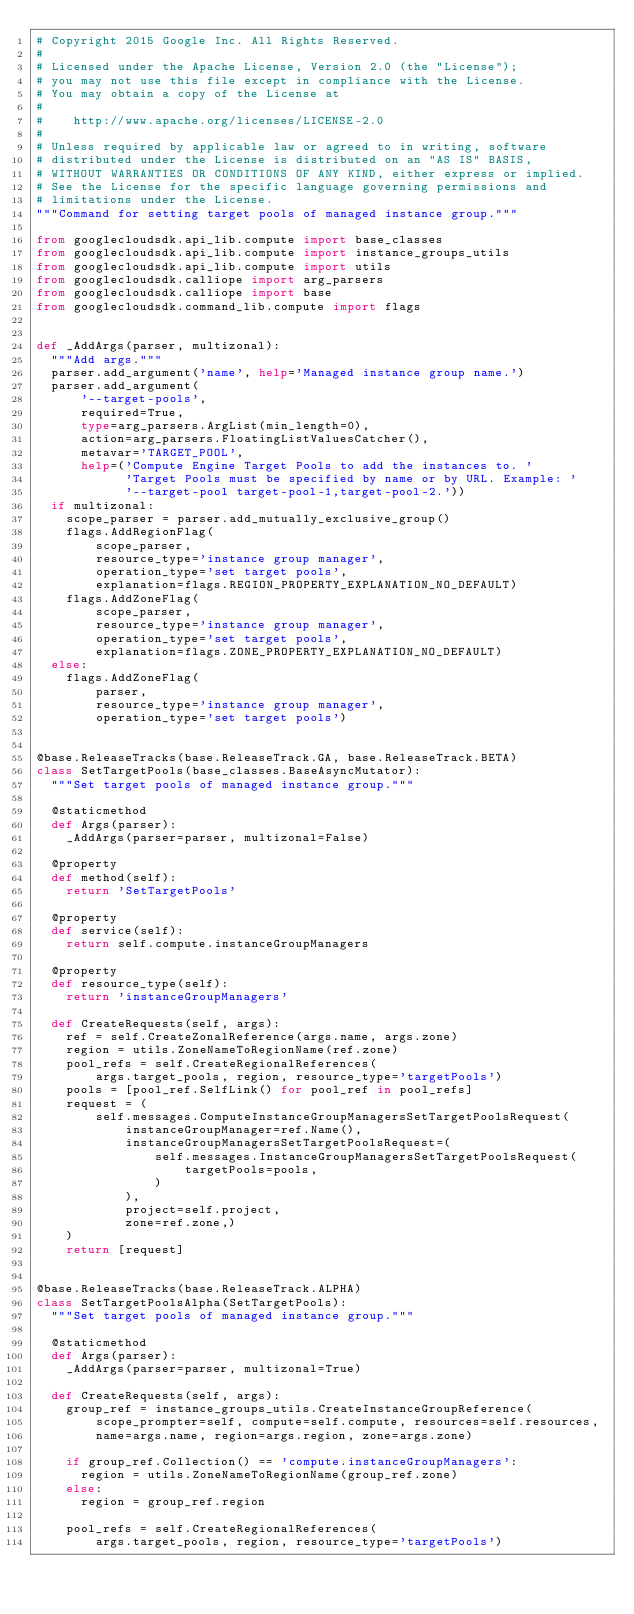Convert code to text. <code><loc_0><loc_0><loc_500><loc_500><_Python_># Copyright 2015 Google Inc. All Rights Reserved.
#
# Licensed under the Apache License, Version 2.0 (the "License");
# you may not use this file except in compliance with the License.
# You may obtain a copy of the License at
#
#    http://www.apache.org/licenses/LICENSE-2.0
#
# Unless required by applicable law or agreed to in writing, software
# distributed under the License is distributed on an "AS IS" BASIS,
# WITHOUT WARRANTIES OR CONDITIONS OF ANY KIND, either express or implied.
# See the License for the specific language governing permissions and
# limitations under the License.
"""Command for setting target pools of managed instance group."""

from googlecloudsdk.api_lib.compute import base_classes
from googlecloudsdk.api_lib.compute import instance_groups_utils
from googlecloudsdk.api_lib.compute import utils
from googlecloudsdk.calliope import arg_parsers
from googlecloudsdk.calliope import base
from googlecloudsdk.command_lib.compute import flags


def _AddArgs(parser, multizonal):
  """Add args."""
  parser.add_argument('name', help='Managed instance group name.')
  parser.add_argument(
      '--target-pools',
      required=True,
      type=arg_parsers.ArgList(min_length=0),
      action=arg_parsers.FloatingListValuesCatcher(),
      metavar='TARGET_POOL',
      help=('Compute Engine Target Pools to add the instances to. '
            'Target Pools must be specified by name or by URL. Example: '
            '--target-pool target-pool-1,target-pool-2.'))
  if multizonal:
    scope_parser = parser.add_mutually_exclusive_group()
    flags.AddRegionFlag(
        scope_parser,
        resource_type='instance group manager',
        operation_type='set target pools',
        explanation=flags.REGION_PROPERTY_EXPLANATION_NO_DEFAULT)
    flags.AddZoneFlag(
        scope_parser,
        resource_type='instance group manager',
        operation_type='set target pools',
        explanation=flags.ZONE_PROPERTY_EXPLANATION_NO_DEFAULT)
  else:
    flags.AddZoneFlag(
        parser,
        resource_type='instance group manager',
        operation_type='set target pools')


@base.ReleaseTracks(base.ReleaseTrack.GA, base.ReleaseTrack.BETA)
class SetTargetPools(base_classes.BaseAsyncMutator):
  """Set target pools of managed instance group."""

  @staticmethod
  def Args(parser):
    _AddArgs(parser=parser, multizonal=False)

  @property
  def method(self):
    return 'SetTargetPools'

  @property
  def service(self):
    return self.compute.instanceGroupManagers

  @property
  def resource_type(self):
    return 'instanceGroupManagers'

  def CreateRequests(self, args):
    ref = self.CreateZonalReference(args.name, args.zone)
    region = utils.ZoneNameToRegionName(ref.zone)
    pool_refs = self.CreateRegionalReferences(
        args.target_pools, region, resource_type='targetPools')
    pools = [pool_ref.SelfLink() for pool_ref in pool_refs]
    request = (
        self.messages.ComputeInstanceGroupManagersSetTargetPoolsRequest(
            instanceGroupManager=ref.Name(),
            instanceGroupManagersSetTargetPoolsRequest=(
                self.messages.InstanceGroupManagersSetTargetPoolsRequest(
                    targetPools=pools,
                )
            ),
            project=self.project,
            zone=ref.zone,)
    )
    return [request]


@base.ReleaseTracks(base.ReleaseTrack.ALPHA)
class SetTargetPoolsAlpha(SetTargetPools):
  """Set target pools of managed instance group."""

  @staticmethod
  def Args(parser):
    _AddArgs(parser=parser, multizonal=True)

  def CreateRequests(self, args):
    group_ref = instance_groups_utils.CreateInstanceGroupReference(
        scope_prompter=self, compute=self.compute, resources=self.resources,
        name=args.name, region=args.region, zone=args.zone)

    if group_ref.Collection() == 'compute.instanceGroupManagers':
      region = utils.ZoneNameToRegionName(group_ref.zone)
    else:
      region = group_ref.region

    pool_refs = self.CreateRegionalReferences(
        args.target_pools, region, resource_type='targetPools')</code> 